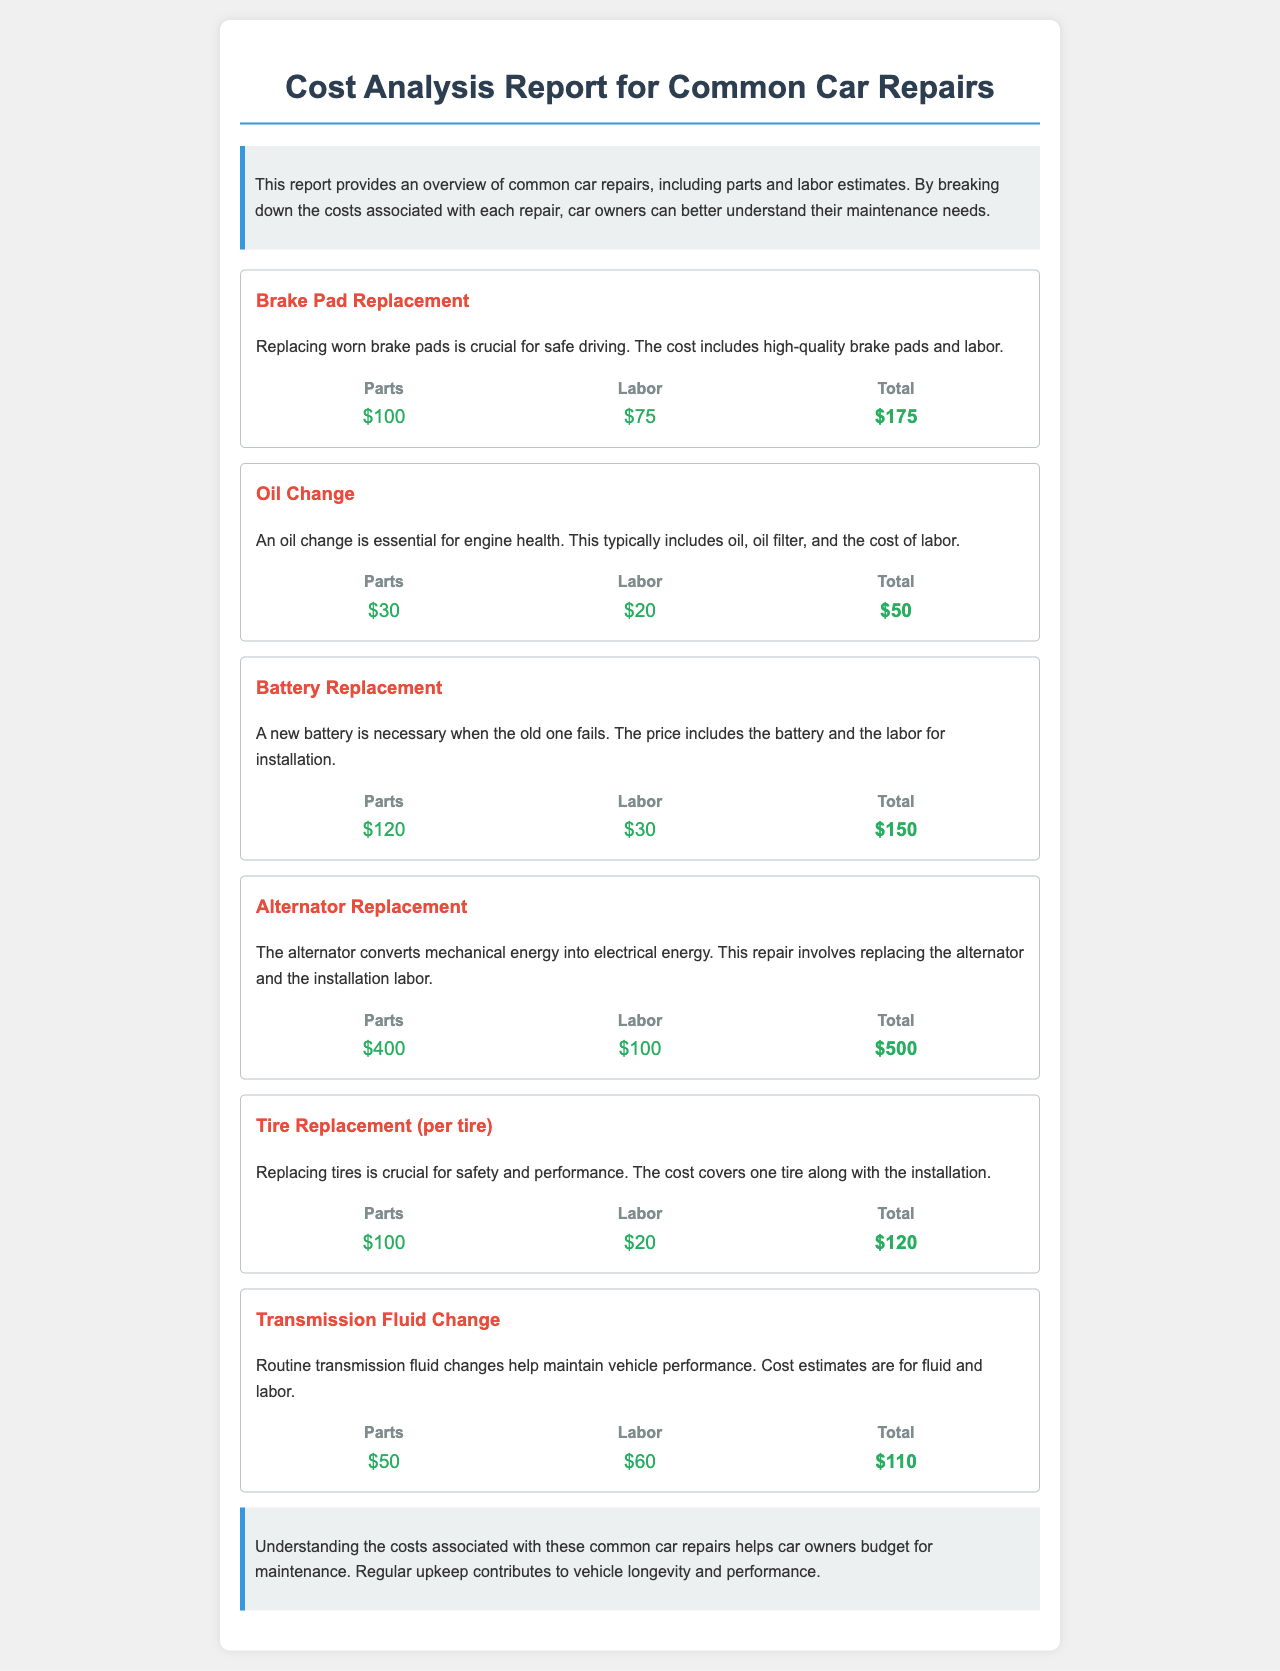What is the cost of Brake Pad Replacement? The cost is the sum of parts and labor for brake pad replacement, which is $100 for parts and $75 for labor.
Answer: $175 How much does an Oil Change cost? The cost of an oil change includes $30 for parts and $20 for labor, totaling $50.
Answer: $50 What is the labor cost for Battery Replacement? The labor cost for battery replacement is listed as $30.
Answer: $30 Which repair has the highest total cost? By comparing the total costs of each repair, the alternator replacement at $500 is the highest.
Answer: Alternator Replacement What are the parts costs for a Tire Replacement? The parts cost for tire replacement is $100.
Answer: $100 What is the total cost for Transmission Fluid Change? The total cost includes $50 for parts and $60 for labor, making it $110.
Answer: $110 How much does replacing a tire cost in terms of labor? The labor cost for replacing a tire is $20.
Answer: $20 What is the main purpose of the report? The report aims to provide an overview of common car repairs and their costs, helping car owners understand maintenance needs.
Answer: Overview of common car repairs and costs What can regular maintenance contribute to? Regular maintenance contributes to vehicle longevity and performance, as stated in the conclusion.
Answer: Vehicle longevity and performance 